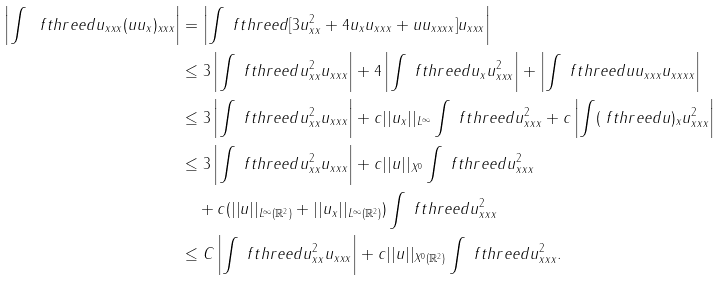Convert formula to latex. <formula><loc_0><loc_0><loc_500><loc_500>\left | \int \ f t h r e e d u _ { x x x } ( u u _ { x } ) _ { x x x } \right | & = \left | \int \ f t h r e e d [ 3 u _ { x x } ^ { 2 } + 4 u _ { x } u _ { x x x } + u u _ { x x x x } ] u _ { x x x } \right | \\ & \leq 3 \left | \int \ f t h r e e d u _ { x x } ^ { 2 } u _ { x x x } \right | + 4 \left | \int \ f t h r e e d u _ { x } u _ { x x x } ^ { 2 } \right | + \left | \int \ f t h r e e d u u _ { x x x } u _ { x x x x } \right | \\ & \leq 3 \left | \int \ f t h r e e d u _ { x x } ^ { 2 } u _ { x x x } \right | + c | | u _ { x } | | _ { L ^ { \infty } } \int \ f t h r e e d u _ { x x x } ^ { 2 } + c \left | \int ( \ f t h r e e d u ) _ { x } u _ { x x x } ^ { 2 } \right | \\ & \leq 3 \left | \int \ f t h r e e d u _ { x x } ^ { 2 } u _ { x x x } \right | + c | | u | | _ { X ^ { 0 } } \int \ f t h r e e d u _ { x x x } ^ { 2 } \\ & \quad + c ( | | u | | _ { L ^ { \infty } ( \mathbb { R } ^ { 2 } ) } + | | u _ { x } | | _ { L ^ { \infty } ( \mathbb { R } ^ { 2 } ) } ) \int \ f t h r e e d u _ { x x x } ^ { 2 } \\ & \leq C \left | \int \ f t h r e e d u _ { x x } ^ { 2 } u _ { x x x } \right | + c | | u | | _ { X ^ { 0 } ( \mathbb { R } ^ { 2 } ) } \int \ f t h r e e d u _ { x x x } ^ { 2 } .</formula> 